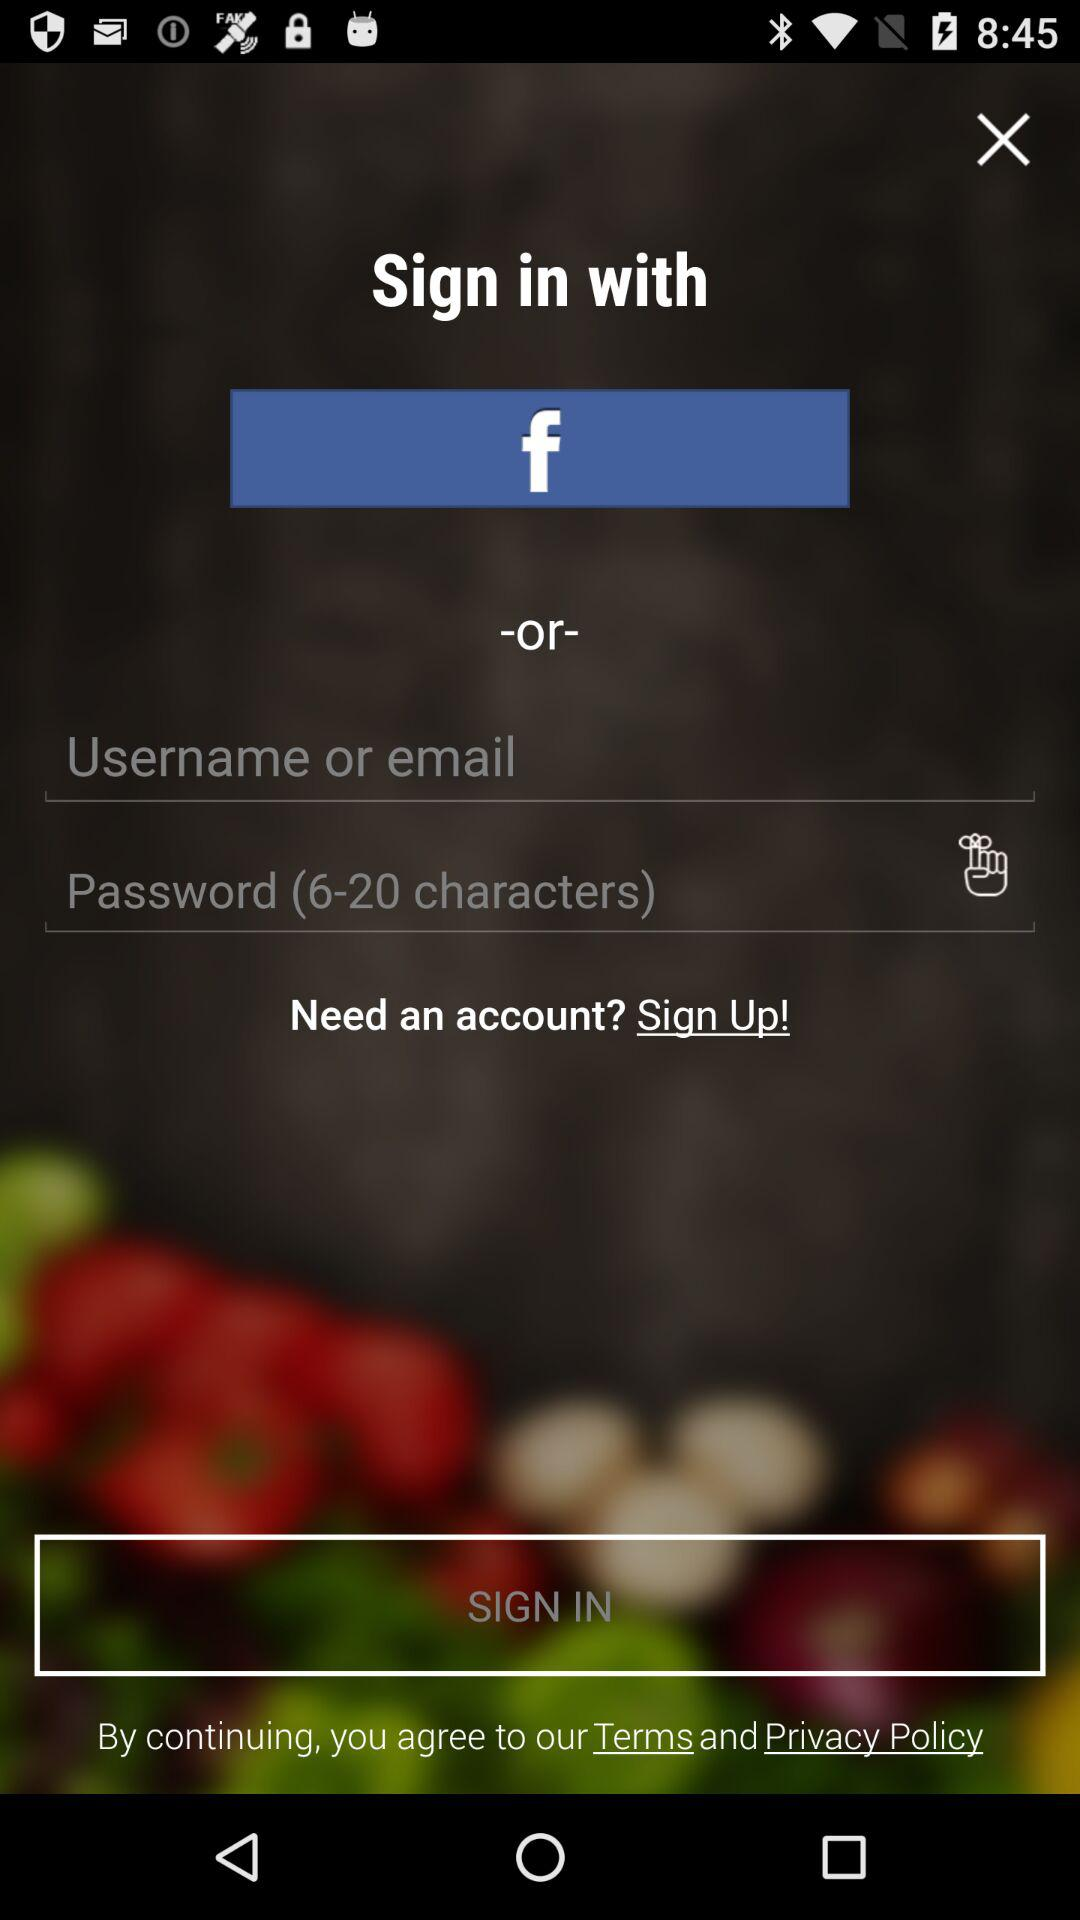What is the character limit for a password? The character limit for a password is 6 to 20. 